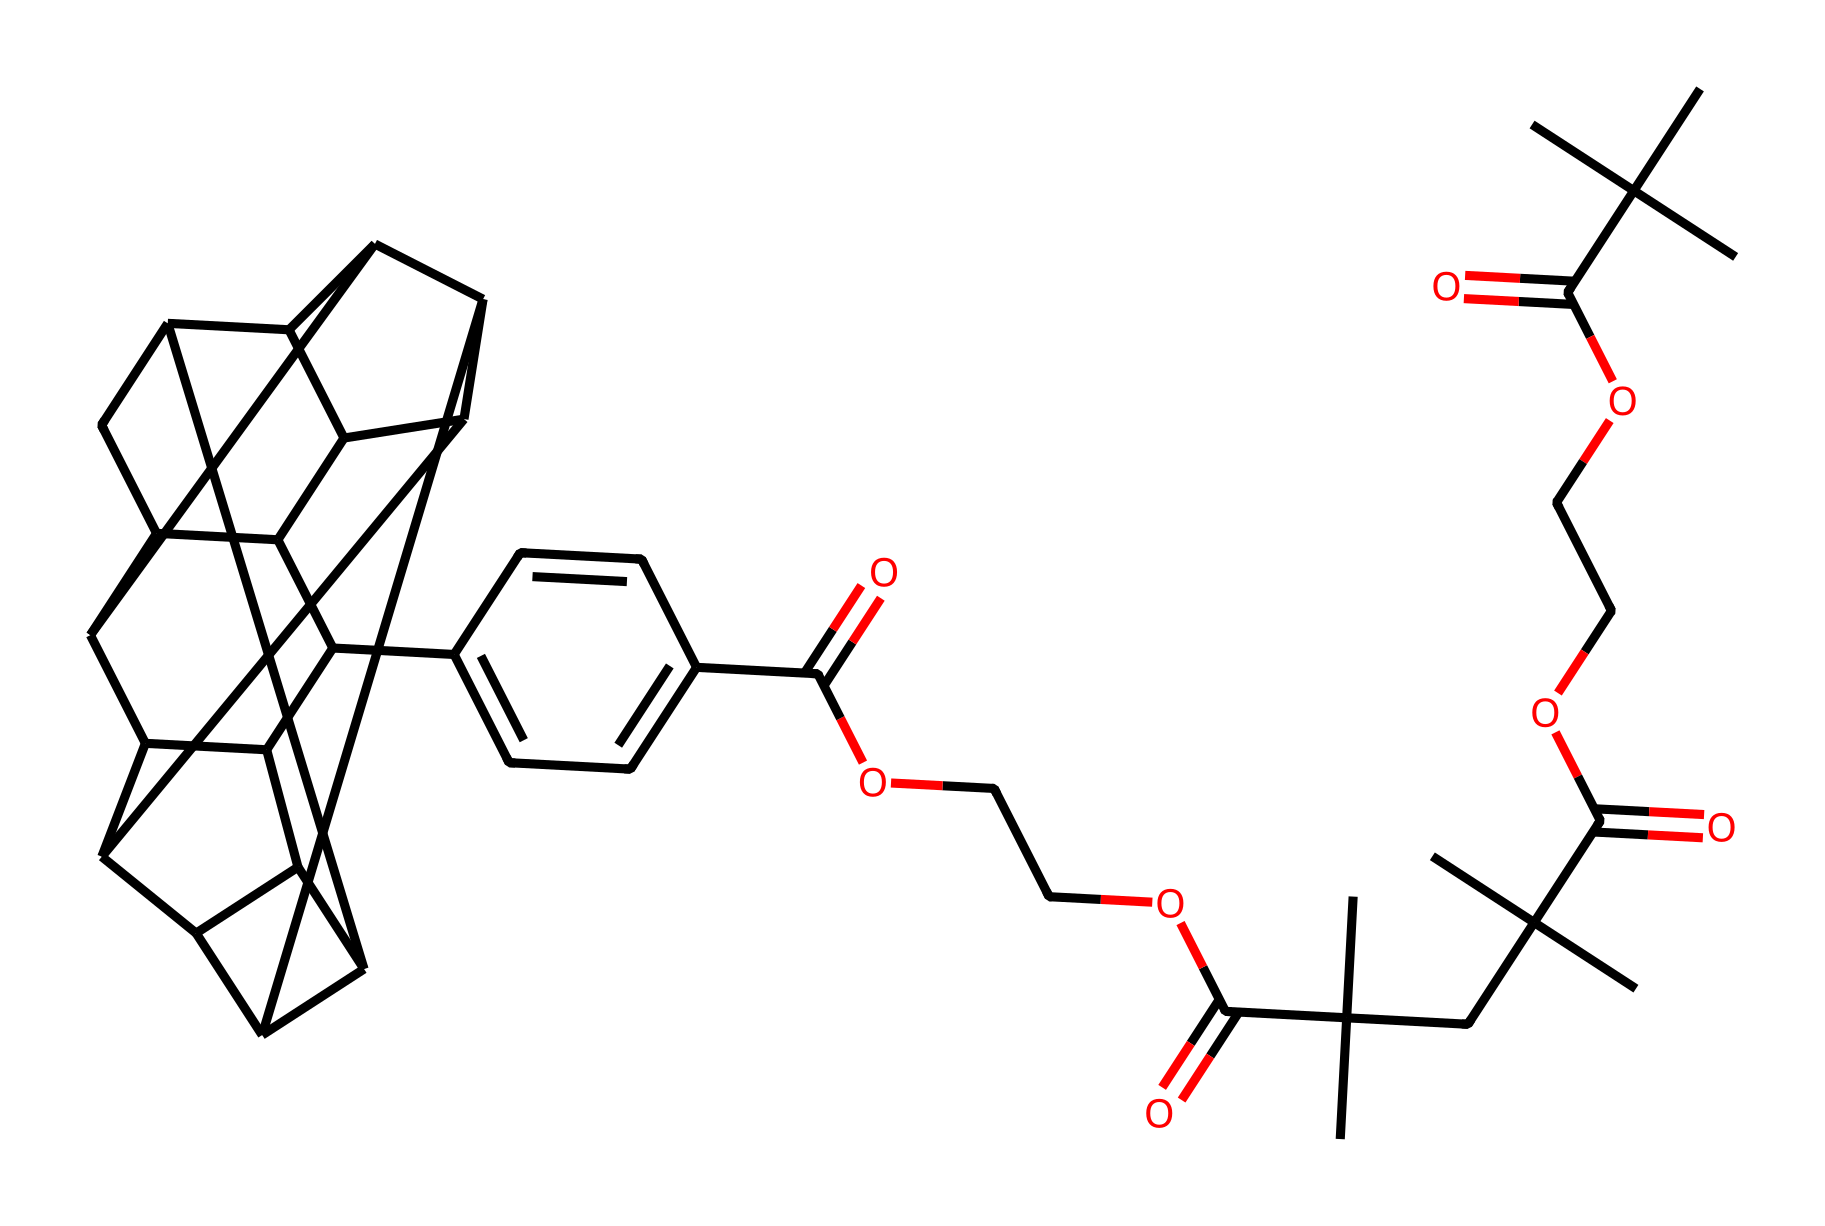How many carbon atoms are in this structure? By analyzing the SMILES representation, we can count the number of carbon atoms depicted in the chemical structure. Each "C" corresponds to a carbon atom, with some being part of the fullerene structure and others being part of the ester and carbonyl groups. Counting them gives a total of 60 carbon atoms.
Answer: 60 What is the functional group present in this compound? Looking at the SMILES code, we can identify the functional groups by recognizing the distinct patterns. The presence of "C(=O)O" indicates a carboxylic acid functional group, while "COC" indicates an ester. Both types are essential for enhancing bonding in dental adhesives.
Answer: carboxyl and ester Does the structure contain any aromatic rings? The structure has an aromatic component that can be identified by the presence of alternating double bonds. Observing "C1=CC=C(C=C1)" suggests a benzene ring is present in the compound, which exhibits the aromatic property.
Answer: yes What type of chemical bonding is predominant in fullerenes? Fullerenes primarily exhibit covalent bonding, characterized by shared pairs of electrons between the carbon atoms that form a network of interconnected rings or cages. This type of bonding is crucial for the stability of fullerenes.
Answer: covalent How many rings are present in the fullerene structure? To determine the number of rings, we can analyze the structure and count the interconnected cycles created by carbon atoms. The structure includes multiple hexagonal and pentagonal rings typical of fullerenes. In this case, there are 12 pentagonal and 20 hexagonal rings present.
Answer: 12 pentagons and 20 hexagons What role do fullerenes play in dental adhesives? In dental adhesives, fullerenes improve the mechanical properties and bonding strength through their unique nanostructures, enhancing the interaction between the adhesive and tooth surface. They can improve durability and reduce wear.
Answer: enhance bonding strength 